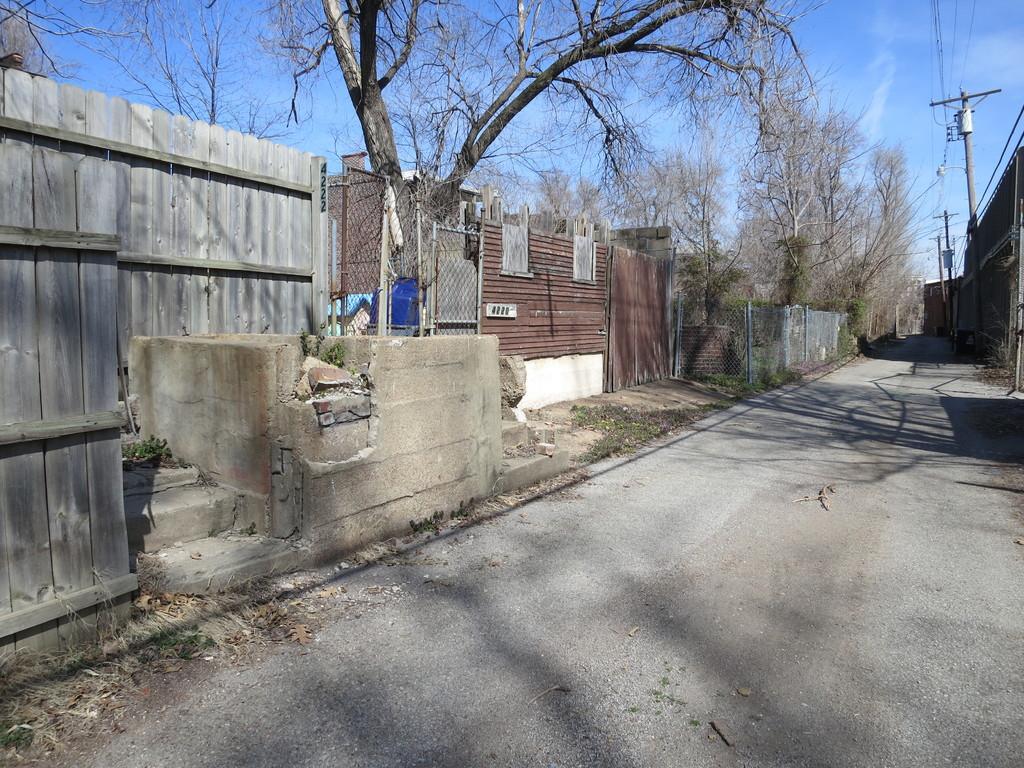Please provide a concise description of this image. In this picture I can see poles, cables, wooden fence, road, trees, and in the background there is sky. 